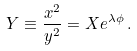<formula> <loc_0><loc_0><loc_500><loc_500>Y \equiv \frac { x ^ { 2 } } { y ^ { 2 } } = X e ^ { \lambda \phi } \, .</formula> 